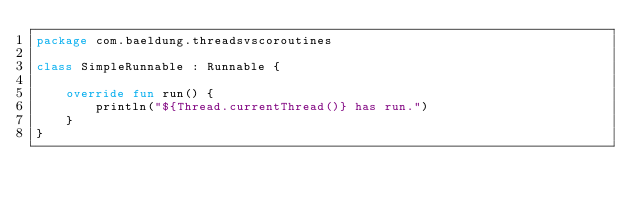<code> <loc_0><loc_0><loc_500><loc_500><_Kotlin_>package com.baeldung.threadsvscoroutines

class SimpleRunnable : Runnable {

    override fun run() {
        println("${Thread.currentThread()} has run.")
    }
}</code> 